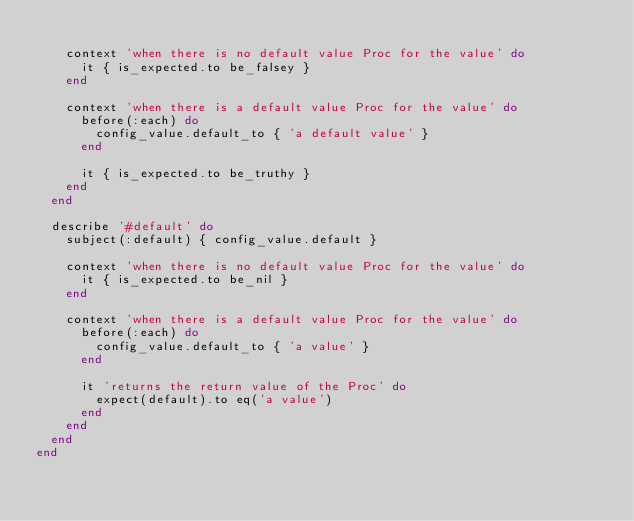Convert code to text. <code><loc_0><loc_0><loc_500><loc_500><_Ruby_>
    context 'when there is no default value Proc for the value' do
      it { is_expected.to be_falsey }
    end

    context 'when there is a default value Proc for the value' do
      before(:each) do
        config_value.default_to { 'a default value' }
      end

      it { is_expected.to be_truthy }
    end
  end

  describe '#default' do
    subject(:default) { config_value.default }

    context 'when there is no default value Proc for the value' do
      it { is_expected.to be_nil }
    end

    context 'when there is a default value Proc for the value' do
      before(:each) do
        config_value.default_to { 'a value' }
      end

      it 'returns the return value of the Proc' do
        expect(default).to eq('a value')
      end
    end
  end
end
</code> 